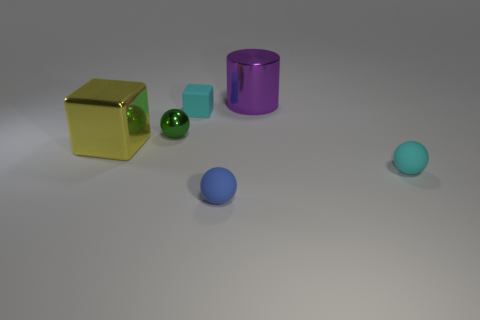Add 3 cyan rubber cubes. How many objects exist? 9 Subtract all cubes. How many objects are left? 4 Subtract 0 red cubes. How many objects are left? 6 Subtract all balls. Subtract all cyan matte blocks. How many objects are left? 2 Add 5 shiny cubes. How many shiny cubes are left? 6 Add 6 small blue cubes. How many small blue cubes exist? 6 